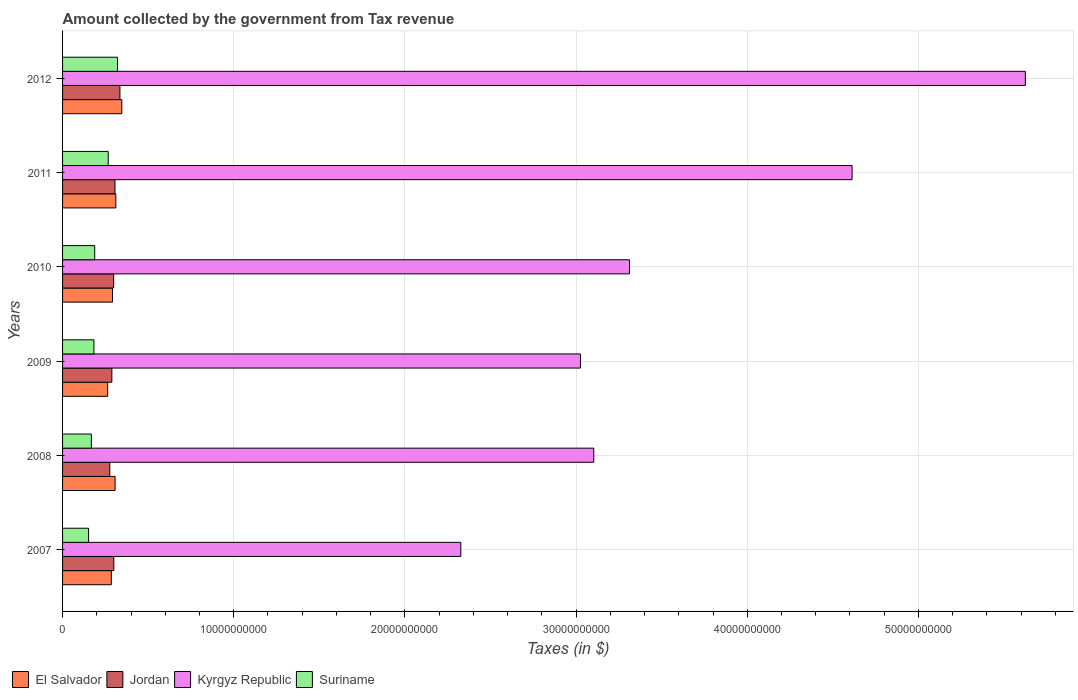Are the number of bars per tick equal to the number of legend labels?
Offer a very short reply. Yes. Are the number of bars on each tick of the Y-axis equal?
Your answer should be compact. Yes. What is the amount collected by the government from tax revenue in Suriname in 2008?
Offer a terse response. 1.68e+09. Across all years, what is the maximum amount collected by the government from tax revenue in Kyrgyz Republic?
Your answer should be compact. 5.62e+1. Across all years, what is the minimum amount collected by the government from tax revenue in El Salvador?
Your response must be concise. 2.64e+09. In which year was the amount collected by the government from tax revenue in El Salvador maximum?
Your response must be concise. 2012. What is the total amount collected by the government from tax revenue in Jordan in the graph?
Your answer should be very brief. 1.80e+1. What is the difference between the amount collected by the government from tax revenue in Jordan in 2008 and that in 2009?
Offer a terse response. -1.22e+08. What is the difference between the amount collected by the government from tax revenue in Suriname in 2008 and the amount collected by the government from tax revenue in El Salvador in 2012?
Give a very brief answer. -1.78e+09. What is the average amount collected by the government from tax revenue in Kyrgyz Republic per year?
Offer a terse response. 3.67e+1. In the year 2008, what is the difference between the amount collected by the government from tax revenue in Suriname and amount collected by the government from tax revenue in Kyrgyz Republic?
Offer a very short reply. -2.94e+1. What is the ratio of the amount collected by the government from tax revenue in Jordan in 2008 to that in 2011?
Ensure brevity in your answer.  0.9. Is the amount collected by the government from tax revenue in El Salvador in 2008 less than that in 2010?
Provide a succinct answer. No. Is the difference between the amount collected by the government from tax revenue in Suriname in 2011 and 2012 greater than the difference between the amount collected by the government from tax revenue in Kyrgyz Republic in 2011 and 2012?
Provide a short and direct response. Yes. What is the difference between the highest and the second highest amount collected by the government from tax revenue in Suriname?
Your response must be concise. 5.46e+08. What is the difference between the highest and the lowest amount collected by the government from tax revenue in Kyrgyz Republic?
Provide a short and direct response. 3.30e+1. Is the sum of the amount collected by the government from tax revenue in Jordan in 2008 and 2010 greater than the maximum amount collected by the government from tax revenue in Kyrgyz Republic across all years?
Keep it short and to the point. No. What does the 1st bar from the top in 2008 represents?
Keep it short and to the point. Suriname. What does the 2nd bar from the bottom in 2009 represents?
Your response must be concise. Jordan. Is it the case that in every year, the sum of the amount collected by the government from tax revenue in El Salvador and amount collected by the government from tax revenue in Kyrgyz Republic is greater than the amount collected by the government from tax revenue in Jordan?
Your response must be concise. Yes. Are all the bars in the graph horizontal?
Give a very brief answer. Yes. Does the graph contain any zero values?
Give a very brief answer. No. How many legend labels are there?
Give a very brief answer. 4. How are the legend labels stacked?
Keep it short and to the point. Horizontal. What is the title of the graph?
Make the answer very short. Amount collected by the government from Tax revenue. What is the label or title of the X-axis?
Your answer should be very brief. Taxes (in $). What is the Taxes (in $) of El Salvador in 2007?
Your response must be concise. 2.85e+09. What is the Taxes (in $) in Jordan in 2007?
Your answer should be very brief. 3.00e+09. What is the Taxes (in $) of Kyrgyz Republic in 2007?
Keep it short and to the point. 2.33e+1. What is the Taxes (in $) of Suriname in 2007?
Provide a succinct answer. 1.52e+09. What is the Taxes (in $) of El Salvador in 2008?
Offer a very short reply. 3.07e+09. What is the Taxes (in $) in Jordan in 2008?
Provide a short and direct response. 2.76e+09. What is the Taxes (in $) in Kyrgyz Republic in 2008?
Your response must be concise. 3.10e+1. What is the Taxes (in $) of Suriname in 2008?
Offer a terse response. 1.68e+09. What is the Taxes (in $) of El Salvador in 2009?
Ensure brevity in your answer.  2.64e+09. What is the Taxes (in $) in Jordan in 2009?
Your response must be concise. 2.88e+09. What is the Taxes (in $) in Kyrgyz Republic in 2009?
Offer a terse response. 3.03e+1. What is the Taxes (in $) of Suriname in 2009?
Offer a very short reply. 1.83e+09. What is the Taxes (in $) in El Salvador in 2010?
Keep it short and to the point. 2.92e+09. What is the Taxes (in $) of Jordan in 2010?
Your response must be concise. 2.99e+09. What is the Taxes (in $) in Kyrgyz Republic in 2010?
Provide a succinct answer. 3.31e+1. What is the Taxes (in $) in Suriname in 2010?
Your response must be concise. 1.88e+09. What is the Taxes (in $) of El Salvador in 2011?
Your response must be concise. 3.11e+09. What is the Taxes (in $) of Jordan in 2011?
Make the answer very short. 3.06e+09. What is the Taxes (in $) of Kyrgyz Republic in 2011?
Ensure brevity in your answer.  4.61e+1. What is the Taxes (in $) in Suriname in 2011?
Offer a terse response. 2.67e+09. What is the Taxes (in $) of El Salvador in 2012?
Your response must be concise. 3.46e+09. What is the Taxes (in $) in Jordan in 2012?
Ensure brevity in your answer.  3.35e+09. What is the Taxes (in $) in Kyrgyz Republic in 2012?
Give a very brief answer. 5.62e+1. What is the Taxes (in $) in Suriname in 2012?
Your answer should be very brief. 3.21e+09. Across all years, what is the maximum Taxes (in $) of El Salvador?
Provide a succinct answer. 3.46e+09. Across all years, what is the maximum Taxes (in $) of Jordan?
Keep it short and to the point. 3.35e+09. Across all years, what is the maximum Taxes (in $) in Kyrgyz Republic?
Your answer should be compact. 5.62e+1. Across all years, what is the maximum Taxes (in $) of Suriname?
Ensure brevity in your answer.  3.21e+09. Across all years, what is the minimum Taxes (in $) of El Salvador?
Provide a succinct answer. 2.64e+09. Across all years, what is the minimum Taxes (in $) in Jordan?
Ensure brevity in your answer.  2.76e+09. Across all years, what is the minimum Taxes (in $) of Kyrgyz Republic?
Ensure brevity in your answer.  2.33e+1. Across all years, what is the minimum Taxes (in $) in Suriname?
Offer a very short reply. 1.52e+09. What is the total Taxes (in $) of El Salvador in the graph?
Your answer should be compact. 1.80e+1. What is the total Taxes (in $) of Jordan in the graph?
Make the answer very short. 1.80e+1. What is the total Taxes (in $) in Kyrgyz Republic in the graph?
Give a very brief answer. 2.20e+11. What is the total Taxes (in $) in Suriname in the graph?
Keep it short and to the point. 1.28e+1. What is the difference between the Taxes (in $) in El Salvador in 2007 and that in 2008?
Offer a terse response. -2.20e+08. What is the difference between the Taxes (in $) of Jordan in 2007 and that in 2008?
Your answer should be very brief. 2.37e+08. What is the difference between the Taxes (in $) of Kyrgyz Republic in 2007 and that in 2008?
Offer a terse response. -7.77e+09. What is the difference between the Taxes (in $) of Suriname in 2007 and that in 2008?
Provide a succinct answer. -1.62e+08. What is the difference between the Taxes (in $) of El Salvador in 2007 and that in 2009?
Offer a very short reply. 2.12e+08. What is the difference between the Taxes (in $) of Jordan in 2007 and that in 2009?
Give a very brief answer. 1.15e+08. What is the difference between the Taxes (in $) of Kyrgyz Republic in 2007 and that in 2009?
Your answer should be very brief. -6.99e+09. What is the difference between the Taxes (in $) of Suriname in 2007 and that in 2009?
Give a very brief answer. -3.11e+08. What is the difference between the Taxes (in $) in El Salvador in 2007 and that in 2010?
Your answer should be very brief. -6.84e+07. What is the difference between the Taxes (in $) of Jordan in 2007 and that in 2010?
Provide a short and direct response. 9.30e+06. What is the difference between the Taxes (in $) of Kyrgyz Republic in 2007 and that in 2010?
Provide a succinct answer. -9.86e+09. What is the difference between the Taxes (in $) in Suriname in 2007 and that in 2010?
Ensure brevity in your answer.  -3.57e+08. What is the difference between the Taxes (in $) of El Salvador in 2007 and that in 2011?
Make the answer very short. -2.64e+08. What is the difference between the Taxes (in $) of Jordan in 2007 and that in 2011?
Provide a succinct answer. -6.70e+07. What is the difference between the Taxes (in $) of Kyrgyz Republic in 2007 and that in 2011?
Give a very brief answer. -2.29e+1. What is the difference between the Taxes (in $) of Suriname in 2007 and that in 2011?
Your answer should be compact. -1.15e+09. What is the difference between the Taxes (in $) in El Salvador in 2007 and that in 2012?
Provide a short and direct response. -6.12e+08. What is the difference between the Taxes (in $) of Jordan in 2007 and that in 2012?
Your answer should be compact. -3.56e+08. What is the difference between the Taxes (in $) of Kyrgyz Republic in 2007 and that in 2012?
Your answer should be very brief. -3.30e+1. What is the difference between the Taxes (in $) in Suriname in 2007 and that in 2012?
Provide a short and direct response. -1.69e+09. What is the difference between the Taxes (in $) of El Salvador in 2008 and that in 2009?
Your answer should be compact. 4.32e+08. What is the difference between the Taxes (in $) in Jordan in 2008 and that in 2009?
Keep it short and to the point. -1.22e+08. What is the difference between the Taxes (in $) in Kyrgyz Republic in 2008 and that in 2009?
Your response must be concise. 7.79e+08. What is the difference between the Taxes (in $) in Suriname in 2008 and that in 2009?
Offer a terse response. -1.49e+08. What is the difference between the Taxes (in $) in El Salvador in 2008 and that in 2010?
Make the answer very short. 1.52e+08. What is the difference between the Taxes (in $) in Jordan in 2008 and that in 2010?
Your response must be concise. -2.28e+08. What is the difference between the Taxes (in $) in Kyrgyz Republic in 2008 and that in 2010?
Your answer should be compact. -2.09e+09. What is the difference between the Taxes (in $) of Suriname in 2008 and that in 2010?
Your answer should be compact. -1.95e+08. What is the difference between the Taxes (in $) in El Salvador in 2008 and that in 2011?
Provide a short and direct response. -4.38e+07. What is the difference between the Taxes (in $) of Jordan in 2008 and that in 2011?
Your response must be concise. -3.04e+08. What is the difference between the Taxes (in $) in Kyrgyz Republic in 2008 and that in 2011?
Make the answer very short. -1.51e+1. What is the difference between the Taxes (in $) in Suriname in 2008 and that in 2011?
Provide a succinct answer. -9.84e+08. What is the difference between the Taxes (in $) in El Salvador in 2008 and that in 2012?
Provide a succinct answer. -3.92e+08. What is the difference between the Taxes (in $) in Jordan in 2008 and that in 2012?
Offer a terse response. -5.93e+08. What is the difference between the Taxes (in $) in Kyrgyz Republic in 2008 and that in 2012?
Keep it short and to the point. -2.52e+1. What is the difference between the Taxes (in $) in Suriname in 2008 and that in 2012?
Give a very brief answer. -1.53e+09. What is the difference between the Taxes (in $) in El Salvador in 2009 and that in 2010?
Make the answer very short. -2.81e+08. What is the difference between the Taxes (in $) of Jordan in 2009 and that in 2010?
Your answer should be very brief. -1.06e+08. What is the difference between the Taxes (in $) of Kyrgyz Republic in 2009 and that in 2010?
Provide a short and direct response. -2.87e+09. What is the difference between the Taxes (in $) of Suriname in 2009 and that in 2010?
Your answer should be compact. -4.60e+07. What is the difference between the Taxes (in $) in El Salvador in 2009 and that in 2011?
Give a very brief answer. -4.76e+08. What is the difference between the Taxes (in $) in Jordan in 2009 and that in 2011?
Offer a very short reply. -1.82e+08. What is the difference between the Taxes (in $) in Kyrgyz Republic in 2009 and that in 2011?
Make the answer very short. -1.59e+1. What is the difference between the Taxes (in $) in Suriname in 2009 and that in 2011?
Keep it short and to the point. -8.35e+08. What is the difference between the Taxes (in $) of El Salvador in 2009 and that in 2012?
Your answer should be compact. -8.25e+08. What is the difference between the Taxes (in $) in Jordan in 2009 and that in 2012?
Offer a very short reply. -4.72e+08. What is the difference between the Taxes (in $) of Kyrgyz Republic in 2009 and that in 2012?
Keep it short and to the point. -2.60e+1. What is the difference between the Taxes (in $) of Suriname in 2009 and that in 2012?
Offer a very short reply. -1.38e+09. What is the difference between the Taxes (in $) of El Salvador in 2010 and that in 2011?
Make the answer very short. -1.95e+08. What is the difference between the Taxes (in $) in Jordan in 2010 and that in 2011?
Provide a short and direct response. -7.63e+07. What is the difference between the Taxes (in $) of Kyrgyz Republic in 2010 and that in 2011?
Offer a terse response. -1.30e+1. What is the difference between the Taxes (in $) in Suriname in 2010 and that in 2011?
Offer a terse response. -7.89e+08. What is the difference between the Taxes (in $) of El Salvador in 2010 and that in 2012?
Give a very brief answer. -5.44e+08. What is the difference between the Taxes (in $) in Jordan in 2010 and that in 2012?
Offer a very short reply. -3.66e+08. What is the difference between the Taxes (in $) of Kyrgyz Republic in 2010 and that in 2012?
Offer a very short reply. -2.31e+1. What is the difference between the Taxes (in $) of Suriname in 2010 and that in 2012?
Your answer should be very brief. -1.33e+09. What is the difference between the Taxes (in $) in El Salvador in 2011 and that in 2012?
Offer a very short reply. -3.48e+08. What is the difference between the Taxes (in $) in Jordan in 2011 and that in 2012?
Make the answer very short. -2.89e+08. What is the difference between the Taxes (in $) of Kyrgyz Republic in 2011 and that in 2012?
Provide a short and direct response. -1.01e+1. What is the difference between the Taxes (in $) in Suriname in 2011 and that in 2012?
Provide a succinct answer. -5.46e+08. What is the difference between the Taxes (in $) of El Salvador in 2007 and the Taxes (in $) of Jordan in 2008?
Ensure brevity in your answer.  9.05e+07. What is the difference between the Taxes (in $) in El Salvador in 2007 and the Taxes (in $) in Kyrgyz Republic in 2008?
Make the answer very short. -2.82e+1. What is the difference between the Taxes (in $) in El Salvador in 2007 and the Taxes (in $) in Suriname in 2008?
Offer a very short reply. 1.17e+09. What is the difference between the Taxes (in $) in Jordan in 2007 and the Taxes (in $) in Kyrgyz Republic in 2008?
Provide a short and direct response. -2.80e+1. What is the difference between the Taxes (in $) of Jordan in 2007 and the Taxes (in $) of Suriname in 2008?
Make the answer very short. 1.31e+09. What is the difference between the Taxes (in $) of Kyrgyz Republic in 2007 and the Taxes (in $) of Suriname in 2008?
Provide a short and direct response. 2.16e+1. What is the difference between the Taxes (in $) in El Salvador in 2007 and the Taxes (in $) in Jordan in 2009?
Ensure brevity in your answer.  -3.13e+07. What is the difference between the Taxes (in $) in El Salvador in 2007 and the Taxes (in $) in Kyrgyz Republic in 2009?
Your response must be concise. -2.74e+1. What is the difference between the Taxes (in $) in El Salvador in 2007 and the Taxes (in $) in Suriname in 2009?
Ensure brevity in your answer.  1.02e+09. What is the difference between the Taxes (in $) of Jordan in 2007 and the Taxes (in $) of Kyrgyz Republic in 2009?
Ensure brevity in your answer.  -2.73e+1. What is the difference between the Taxes (in $) of Jordan in 2007 and the Taxes (in $) of Suriname in 2009?
Ensure brevity in your answer.  1.16e+09. What is the difference between the Taxes (in $) of Kyrgyz Republic in 2007 and the Taxes (in $) of Suriname in 2009?
Offer a very short reply. 2.14e+1. What is the difference between the Taxes (in $) in El Salvador in 2007 and the Taxes (in $) in Jordan in 2010?
Give a very brief answer. -1.37e+08. What is the difference between the Taxes (in $) in El Salvador in 2007 and the Taxes (in $) in Kyrgyz Republic in 2010?
Offer a terse response. -3.03e+1. What is the difference between the Taxes (in $) in El Salvador in 2007 and the Taxes (in $) in Suriname in 2010?
Offer a very short reply. 9.71e+08. What is the difference between the Taxes (in $) in Jordan in 2007 and the Taxes (in $) in Kyrgyz Republic in 2010?
Keep it short and to the point. -3.01e+1. What is the difference between the Taxes (in $) in Jordan in 2007 and the Taxes (in $) in Suriname in 2010?
Make the answer very short. 1.12e+09. What is the difference between the Taxes (in $) in Kyrgyz Republic in 2007 and the Taxes (in $) in Suriname in 2010?
Your answer should be compact. 2.14e+1. What is the difference between the Taxes (in $) in El Salvador in 2007 and the Taxes (in $) in Jordan in 2011?
Make the answer very short. -2.14e+08. What is the difference between the Taxes (in $) in El Salvador in 2007 and the Taxes (in $) in Kyrgyz Republic in 2011?
Provide a short and direct response. -4.33e+1. What is the difference between the Taxes (in $) in El Salvador in 2007 and the Taxes (in $) in Suriname in 2011?
Offer a terse response. 1.82e+08. What is the difference between the Taxes (in $) in Jordan in 2007 and the Taxes (in $) in Kyrgyz Republic in 2011?
Provide a short and direct response. -4.31e+1. What is the difference between the Taxes (in $) in Jordan in 2007 and the Taxes (in $) in Suriname in 2011?
Give a very brief answer. 3.29e+08. What is the difference between the Taxes (in $) of Kyrgyz Republic in 2007 and the Taxes (in $) of Suriname in 2011?
Give a very brief answer. 2.06e+1. What is the difference between the Taxes (in $) in El Salvador in 2007 and the Taxes (in $) in Jordan in 2012?
Provide a short and direct response. -5.03e+08. What is the difference between the Taxes (in $) in El Salvador in 2007 and the Taxes (in $) in Kyrgyz Republic in 2012?
Your answer should be very brief. -5.34e+1. What is the difference between the Taxes (in $) in El Salvador in 2007 and the Taxes (in $) in Suriname in 2012?
Provide a succinct answer. -3.64e+08. What is the difference between the Taxes (in $) of Jordan in 2007 and the Taxes (in $) of Kyrgyz Republic in 2012?
Provide a short and direct response. -5.33e+1. What is the difference between the Taxes (in $) in Jordan in 2007 and the Taxes (in $) in Suriname in 2012?
Keep it short and to the point. -2.17e+08. What is the difference between the Taxes (in $) of Kyrgyz Republic in 2007 and the Taxes (in $) of Suriname in 2012?
Offer a very short reply. 2.01e+1. What is the difference between the Taxes (in $) of El Salvador in 2008 and the Taxes (in $) of Jordan in 2009?
Provide a succinct answer. 1.89e+08. What is the difference between the Taxes (in $) in El Salvador in 2008 and the Taxes (in $) in Kyrgyz Republic in 2009?
Ensure brevity in your answer.  -2.72e+1. What is the difference between the Taxes (in $) in El Salvador in 2008 and the Taxes (in $) in Suriname in 2009?
Give a very brief answer. 1.24e+09. What is the difference between the Taxes (in $) of Jordan in 2008 and the Taxes (in $) of Kyrgyz Republic in 2009?
Provide a succinct answer. -2.75e+1. What is the difference between the Taxes (in $) of Jordan in 2008 and the Taxes (in $) of Suriname in 2009?
Provide a succinct answer. 9.26e+08. What is the difference between the Taxes (in $) in Kyrgyz Republic in 2008 and the Taxes (in $) in Suriname in 2009?
Provide a succinct answer. 2.92e+1. What is the difference between the Taxes (in $) of El Salvador in 2008 and the Taxes (in $) of Jordan in 2010?
Ensure brevity in your answer.  8.27e+07. What is the difference between the Taxes (in $) in El Salvador in 2008 and the Taxes (in $) in Kyrgyz Republic in 2010?
Your response must be concise. -3.01e+1. What is the difference between the Taxes (in $) of El Salvador in 2008 and the Taxes (in $) of Suriname in 2010?
Provide a succinct answer. 1.19e+09. What is the difference between the Taxes (in $) of Jordan in 2008 and the Taxes (in $) of Kyrgyz Republic in 2010?
Provide a short and direct response. -3.04e+1. What is the difference between the Taxes (in $) in Jordan in 2008 and the Taxes (in $) in Suriname in 2010?
Give a very brief answer. 8.80e+08. What is the difference between the Taxes (in $) of Kyrgyz Republic in 2008 and the Taxes (in $) of Suriname in 2010?
Your response must be concise. 2.92e+1. What is the difference between the Taxes (in $) in El Salvador in 2008 and the Taxes (in $) in Jordan in 2011?
Provide a succinct answer. 6.40e+06. What is the difference between the Taxes (in $) of El Salvador in 2008 and the Taxes (in $) of Kyrgyz Republic in 2011?
Your response must be concise. -4.31e+1. What is the difference between the Taxes (in $) of El Salvador in 2008 and the Taxes (in $) of Suriname in 2011?
Offer a very short reply. 4.02e+08. What is the difference between the Taxes (in $) in Jordan in 2008 and the Taxes (in $) in Kyrgyz Republic in 2011?
Provide a succinct answer. -4.34e+1. What is the difference between the Taxes (in $) of Jordan in 2008 and the Taxes (in $) of Suriname in 2011?
Your response must be concise. 9.14e+07. What is the difference between the Taxes (in $) of Kyrgyz Republic in 2008 and the Taxes (in $) of Suriname in 2011?
Provide a succinct answer. 2.84e+1. What is the difference between the Taxes (in $) of El Salvador in 2008 and the Taxes (in $) of Jordan in 2012?
Provide a short and direct response. -2.83e+08. What is the difference between the Taxes (in $) of El Salvador in 2008 and the Taxes (in $) of Kyrgyz Republic in 2012?
Give a very brief answer. -5.32e+1. What is the difference between the Taxes (in $) of El Salvador in 2008 and the Taxes (in $) of Suriname in 2012?
Keep it short and to the point. -1.44e+08. What is the difference between the Taxes (in $) of Jordan in 2008 and the Taxes (in $) of Kyrgyz Republic in 2012?
Ensure brevity in your answer.  -5.35e+1. What is the difference between the Taxes (in $) of Jordan in 2008 and the Taxes (in $) of Suriname in 2012?
Your answer should be very brief. -4.54e+08. What is the difference between the Taxes (in $) in Kyrgyz Republic in 2008 and the Taxes (in $) in Suriname in 2012?
Give a very brief answer. 2.78e+1. What is the difference between the Taxes (in $) in El Salvador in 2009 and the Taxes (in $) in Jordan in 2010?
Make the answer very short. -3.50e+08. What is the difference between the Taxes (in $) in El Salvador in 2009 and the Taxes (in $) in Kyrgyz Republic in 2010?
Offer a terse response. -3.05e+1. What is the difference between the Taxes (in $) of El Salvador in 2009 and the Taxes (in $) of Suriname in 2010?
Provide a succinct answer. 7.58e+08. What is the difference between the Taxes (in $) in Jordan in 2009 and the Taxes (in $) in Kyrgyz Republic in 2010?
Give a very brief answer. -3.02e+1. What is the difference between the Taxes (in $) in Jordan in 2009 and the Taxes (in $) in Suriname in 2010?
Ensure brevity in your answer.  1.00e+09. What is the difference between the Taxes (in $) in Kyrgyz Republic in 2009 and the Taxes (in $) in Suriname in 2010?
Ensure brevity in your answer.  2.84e+1. What is the difference between the Taxes (in $) of El Salvador in 2009 and the Taxes (in $) of Jordan in 2011?
Keep it short and to the point. -4.26e+08. What is the difference between the Taxes (in $) of El Salvador in 2009 and the Taxes (in $) of Kyrgyz Republic in 2011?
Offer a terse response. -4.35e+1. What is the difference between the Taxes (in $) in El Salvador in 2009 and the Taxes (in $) in Suriname in 2011?
Provide a short and direct response. -3.05e+07. What is the difference between the Taxes (in $) in Jordan in 2009 and the Taxes (in $) in Kyrgyz Republic in 2011?
Your answer should be compact. -4.32e+1. What is the difference between the Taxes (in $) in Jordan in 2009 and the Taxes (in $) in Suriname in 2011?
Your answer should be compact. 2.13e+08. What is the difference between the Taxes (in $) of Kyrgyz Republic in 2009 and the Taxes (in $) of Suriname in 2011?
Keep it short and to the point. 2.76e+1. What is the difference between the Taxes (in $) of El Salvador in 2009 and the Taxes (in $) of Jordan in 2012?
Keep it short and to the point. -7.15e+08. What is the difference between the Taxes (in $) of El Salvador in 2009 and the Taxes (in $) of Kyrgyz Republic in 2012?
Your answer should be compact. -5.36e+1. What is the difference between the Taxes (in $) in El Salvador in 2009 and the Taxes (in $) in Suriname in 2012?
Make the answer very short. -5.76e+08. What is the difference between the Taxes (in $) of Jordan in 2009 and the Taxes (in $) of Kyrgyz Republic in 2012?
Provide a short and direct response. -5.34e+1. What is the difference between the Taxes (in $) of Jordan in 2009 and the Taxes (in $) of Suriname in 2012?
Offer a terse response. -3.33e+08. What is the difference between the Taxes (in $) in Kyrgyz Republic in 2009 and the Taxes (in $) in Suriname in 2012?
Ensure brevity in your answer.  2.70e+1. What is the difference between the Taxes (in $) in El Salvador in 2010 and the Taxes (in $) in Jordan in 2011?
Your response must be concise. -1.45e+08. What is the difference between the Taxes (in $) of El Salvador in 2010 and the Taxes (in $) of Kyrgyz Republic in 2011?
Provide a short and direct response. -4.32e+1. What is the difference between the Taxes (in $) in El Salvador in 2010 and the Taxes (in $) in Suriname in 2011?
Your response must be concise. 2.50e+08. What is the difference between the Taxes (in $) of Jordan in 2010 and the Taxes (in $) of Kyrgyz Republic in 2011?
Your answer should be compact. -4.31e+1. What is the difference between the Taxes (in $) of Jordan in 2010 and the Taxes (in $) of Suriname in 2011?
Provide a short and direct response. 3.19e+08. What is the difference between the Taxes (in $) of Kyrgyz Republic in 2010 and the Taxes (in $) of Suriname in 2011?
Your answer should be compact. 3.05e+1. What is the difference between the Taxes (in $) in El Salvador in 2010 and the Taxes (in $) in Jordan in 2012?
Keep it short and to the point. -4.34e+08. What is the difference between the Taxes (in $) of El Salvador in 2010 and the Taxes (in $) of Kyrgyz Republic in 2012?
Offer a very short reply. -5.33e+1. What is the difference between the Taxes (in $) in El Salvador in 2010 and the Taxes (in $) in Suriname in 2012?
Ensure brevity in your answer.  -2.95e+08. What is the difference between the Taxes (in $) in Jordan in 2010 and the Taxes (in $) in Kyrgyz Republic in 2012?
Provide a succinct answer. -5.33e+1. What is the difference between the Taxes (in $) in Jordan in 2010 and the Taxes (in $) in Suriname in 2012?
Your answer should be compact. -2.27e+08. What is the difference between the Taxes (in $) in Kyrgyz Republic in 2010 and the Taxes (in $) in Suriname in 2012?
Provide a succinct answer. 2.99e+1. What is the difference between the Taxes (in $) of El Salvador in 2011 and the Taxes (in $) of Jordan in 2012?
Your response must be concise. -2.39e+08. What is the difference between the Taxes (in $) in El Salvador in 2011 and the Taxes (in $) in Kyrgyz Republic in 2012?
Give a very brief answer. -5.31e+1. What is the difference between the Taxes (in $) of El Salvador in 2011 and the Taxes (in $) of Suriname in 2012?
Offer a terse response. -1.00e+08. What is the difference between the Taxes (in $) of Jordan in 2011 and the Taxes (in $) of Kyrgyz Republic in 2012?
Your answer should be compact. -5.32e+1. What is the difference between the Taxes (in $) of Jordan in 2011 and the Taxes (in $) of Suriname in 2012?
Give a very brief answer. -1.50e+08. What is the difference between the Taxes (in $) of Kyrgyz Republic in 2011 and the Taxes (in $) of Suriname in 2012?
Ensure brevity in your answer.  4.29e+1. What is the average Taxes (in $) in El Salvador per year?
Provide a succinct answer. 3.01e+09. What is the average Taxes (in $) in Jordan per year?
Ensure brevity in your answer.  3.01e+09. What is the average Taxes (in $) in Kyrgyz Republic per year?
Ensure brevity in your answer.  3.67e+1. What is the average Taxes (in $) in Suriname per year?
Provide a short and direct response. 2.13e+09. In the year 2007, what is the difference between the Taxes (in $) in El Salvador and Taxes (in $) in Jordan?
Your answer should be compact. -1.47e+08. In the year 2007, what is the difference between the Taxes (in $) in El Salvador and Taxes (in $) in Kyrgyz Republic?
Provide a short and direct response. -2.04e+1. In the year 2007, what is the difference between the Taxes (in $) in El Salvador and Taxes (in $) in Suriname?
Make the answer very short. 1.33e+09. In the year 2007, what is the difference between the Taxes (in $) in Jordan and Taxes (in $) in Kyrgyz Republic?
Offer a terse response. -2.03e+1. In the year 2007, what is the difference between the Taxes (in $) in Jordan and Taxes (in $) in Suriname?
Give a very brief answer. 1.47e+09. In the year 2007, what is the difference between the Taxes (in $) in Kyrgyz Republic and Taxes (in $) in Suriname?
Offer a terse response. 2.17e+1. In the year 2008, what is the difference between the Taxes (in $) of El Salvador and Taxes (in $) of Jordan?
Offer a terse response. 3.10e+08. In the year 2008, what is the difference between the Taxes (in $) in El Salvador and Taxes (in $) in Kyrgyz Republic?
Provide a succinct answer. -2.80e+1. In the year 2008, what is the difference between the Taxes (in $) of El Salvador and Taxes (in $) of Suriname?
Provide a succinct answer. 1.39e+09. In the year 2008, what is the difference between the Taxes (in $) in Jordan and Taxes (in $) in Kyrgyz Republic?
Provide a short and direct response. -2.83e+1. In the year 2008, what is the difference between the Taxes (in $) of Jordan and Taxes (in $) of Suriname?
Offer a terse response. 1.08e+09. In the year 2008, what is the difference between the Taxes (in $) in Kyrgyz Republic and Taxes (in $) in Suriname?
Your response must be concise. 2.94e+1. In the year 2009, what is the difference between the Taxes (in $) in El Salvador and Taxes (in $) in Jordan?
Your answer should be compact. -2.44e+08. In the year 2009, what is the difference between the Taxes (in $) in El Salvador and Taxes (in $) in Kyrgyz Republic?
Give a very brief answer. -2.76e+1. In the year 2009, what is the difference between the Taxes (in $) in El Salvador and Taxes (in $) in Suriname?
Provide a succinct answer. 8.04e+08. In the year 2009, what is the difference between the Taxes (in $) in Jordan and Taxes (in $) in Kyrgyz Republic?
Provide a short and direct response. -2.74e+1. In the year 2009, what is the difference between the Taxes (in $) in Jordan and Taxes (in $) in Suriname?
Offer a very short reply. 1.05e+09. In the year 2009, what is the difference between the Taxes (in $) of Kyrgyz Republic and Taxes (in $) of Suriname?
Provide a short and direct response. 2.84e+1. In the year 2010, what is the difference between the Taxes (in $) of El Salvador and Taxes (in $) of Jordan?
Ensure brevity in your answer.  -6.89e+07. In the year 2010, what is the difference between the Taxes (in $) in El Salvador and Taxes (in $) in Kyrgyz Republic?
Provide a succinct answer. -3.02e+1. In the year 2010, what is the difference between the Taxes (in $) in El Salvador and Taxes (in $) in Suriname?
Offer a terse response. 1.04e+09. In the year 2010, what is the difference between the Taxes (in $) of Jordan and Taxes (in $) of Kyrgyz Republic?
Your response must be concise. -3.01e+1. In the year 2010, what is the difference between the Taxes (in $) of Jordan and Taxes (in $) of Suriname?
Ensure brevity in your answer.  1.11e+09. In the year 2010, what is the difference between the Taxes (in $) of Kyrgyz Republic and Taxes (in $) of Suriname?
Provide a short and direct response. 3.12e+1. In the year 2011, what is the difference between the Taxes (in $) in El Salvador and Taxes (in $) in Jordan?
Your response must be concise. 5.02e+07. In the year 2011, what is the difference between the Taxes (in $) in El Salvador and Taxes (in $) in Kyrgyz Republic?
Your answer should be compact. -4.30e+1. In the year 2011, what is the difference between the Taxes (in $) in El Salvador and Taxes (in $) in Suriname?
Give a very brief answer. 4.46e+08. In the year 2011, what is the difference between the Taxes (in $) in Jordan and Taxes (in $) in Kyrgyz Republic?
Give a very brief answer. -4.31e+1. In the year 2011, what is the difference between the Taxes (in $) in Jordan and Taxes (in $) in Suriname?
Keep it short and to the point. 3.96e+08. In the year 2011, what is the difference between the Taxes (in $) in Kyrgyz Republic and Taxes (in $) in Suriname?
Provide a succinct answer. 4.35e+1. In the year 2012, what is the difference between the Taxes (in $) in El Salvador and Taxes (in $) in Jordan?
Give a very brief answer. 1.09e+08. In the year 2012, what is the difference between the Taxes (in $) in El Salvador and Taxes (in $) in Kyrgyz Republic?
Your answer should be compact. -5.28e+1. In the year 2012, what is the difference between the Taxes (in $) in El Salvador and Taxes (in $) in Suriname?
Keep it short and to the point. 2.48e+08. In the year 2012, what is the difference between the Taxes (in $) of Jordan and Taxes (in $) of Kyrgyz Republic?
Provide a succinct answer. -5.29e+1. In the year 2012, what is the difference between the Taxes (in $) of Jordan and Taxes (in $) of Suriname?
Your answer should be compact. 1.39e+08. In the year 2012, what is the difference between the Taxes (in $) in Kyrgyz Republic and Taxes (in $) in Suriname?
Make the answer very short. 5.30e+1. What is the ratio of the Taxes (in $) of El Salvador in 2007 to that in 2008?
Keep it short and to the point. 0.93. What is the ratio of the Taxes (in $) in Jordan in 2007 to that in 2008?
Offer a very short reply. 1.09. What is the ratio of the Taxes (in $) of Kyrgyz Republic in 2007 to that in 2008?
Offer a very short reply. 0.75. What is the ratio of the Taxes (in $) in Suriname in 2007 to that in 2008?
Keep it short and to the point. 0.9. What is the ratio of the Taxes (in $) of El Salvador in 2007 to that in 2009?
Your answer should be compact. 1.08. What is the ratio of the Taxes (in $) in Jordan in 2007 to that in 2009?
Make the answer very short. 1.04. What is the ratio of the Taxes (in $) in Kyrgyz Republic in 2007 to that in 2009?
Provide a succinct answer. 0.77. What is the ratio of the Taxes (in $) in Suriname in 2007 to that in 2009?
Ensure brevity in your answer.  0.83. What is the ratio of the Taxes (in $) in El Salvador in 2007 to that in 2010?
Offer a very short reply. 0.98. What is the ratio of the Taxes (in $) in Jordan in 2007 to that in 2010?
Your answer should be compact. 1. What is the ratio of the Taxes (in $) of Kyrgyz Republic in 2007 to that in 2010?
Your answer should be compact. 0.7. What is the ratio of the Taxes (in $) in Suriname in 2007 to that in 2010?
Give a very brief answer. 0.81. What is the ratio of the Taxes (in $) of El Salvador in 2007 to that in 2011?
Your answer should be compact. 0.92. What is the ratio of the Taxes (in $) of Jordan in 2007 to that in 2011?
Your response must be concise. 0.98. What is the ratio of the Taxes (in $) in Kyrgyz Republic in 2007 to that in 2011?
Ensure brevity in your answer.  0.5. What is the ratio of the Taxes (in $) of Suriname in 2007 to that in 2011?
Make the answer very short. 0.57. What is the ratio of the Taxes (in $) in El Salvador in 2007 to that in 2012?
Your answer should be very brief. 0.82. What is the ratio of the Taxes (in $) of Jordan in 2007 to that in 2012?
Offer a very short reply. 0.89. What is the ratio of the Taxes (in $) in Kyrgyz Republic in 2007 to that in 2012?
Make the answer very short. 0.41. What is the ratio of the Taxes (in $) in Suriname in 2007 to that in 2012?
Give a very brief answer. 0.47. What is the ratio of the Taxes (in $) in El Salvador in 2008 to that in 2009?
Provide a short and direct response. 1.16. What is the ratio of the Taxes (in $) in Jordan in 2008 to that in 2009?
Your answer should be compact. 0.96. What is the ratio of the Taxes (in $) in Kyrgyz Republic in 2008 to that in 2009?
Provide a succinct answer. 1.03. What is the ratio of the Taxes (in $) in Suriname in 2008 to that in 2009?
Make the answer very short. 0.92. What is the ratio of the Taxes (in $) in El Salvador in 2008 to that in 2010?
Give a very brief answer. 1.05. What is the ratio of the Taxes (in $) of Jordan in 2008 to that in 2010?
Give a very brief answer. 0.92. What is the ratio of the Taxes (in $) in Kyrgyz Republic in 2008 to that in 2010?
Make the answer very short. 0.94. What is the ratio of the Taxes (in $) in Suriname in 2008 to that in 2010?
Offer a terse response. 0.9. What is the ratio of the Taxes (in $) of El Salvador in 2008 to that in 2011?
Offer a terse response. 0.99. What is the ratio of the Taxes (in $) in Jordan in 2008 to that in 2011?
Keep it short and to the point. 0.9. What is the ratio of the Taxes (in $) of Kyrgyz Republic in 2008 to that in 2011?
Give a very brief answer. 0.67. What is the ratio of the Taxes (in $) of Suriname in 2008 to that in 2011?
Make the answer very short. 0.63. What is the ratio of the Taxes (in $) in El Salvador in 2008 to that in 2012?
Offer a very short reply. 0.89. What is the ratio of the Taxes (in $) in Jordan in 2008 to that in 2012?
Give a very brief answer. 0.82. What is the ratio of the Taxes (in $) of Kyrgyz Republic in 2008 to that in 2012?
Provide a short and direct response. 0.55. What is the ratio of the Taxes (in $) of Suriname in 2008 to that in 2012?
Make the answer very short. 0.52. What is the ratio of the Taxes (in $) in El Salvador in 2009 to that in 2010?
Your answer should be compact. 0.9. What is the ratio of the Taxes (in $) in Jordan in 2009 to that in 2010?
Keep it short and to the point. 0.96. What is the ratio of the Taxes (in $) in Kyrgyz Republic in 2009 to that in 2010?
Your answer should be compact. 0.91. What is the ratio of the Taxes (in $) in Suriname in 2009 to that in 2010?
Your answer should be compact. 0.98. What is the ratio of the Taxes (in $) in El Salvador in 2009 to that in 2011?
Give a very brief answer. 0.85. What is the ratio of the Taxes (in $) of Jordan in 2009 to that in 2011?
Offer a terse response. 0.94. What is the ratio of the Taxes (in $) of Kyrgyz Republic in 2009 to that in 2011?
Make the answer very short. 0.66. What is the ratio of the Taxes (in $) in Suriname in 2009 to that in 2011?
Your answer should be compact. 0.69. What is the ratio of the Taxes (in $) in El Salvador in 2009 to that in 2012?
Provide a succinct answer. 0.76. What is the ratio of the Taxes (in $) of Jordan in 2009 to that in 2012?
Provide a succinct answer. 0.86. What is the ratio of the Taxes (in $) in Kyrgyz Republic in 2009 to that in 2012?
Your answer should be compact. 0.54. What is the ratio of the Taxes (in $) of Suriname in 2009 to that in 2012?
Give a very brief answer. 0.57. What is the ratio of the Taxes (in $) of El Salvador in 2010 to that in 2011?
Provide a short and direct response. 0.94. What is the ratio of the Taxes (in $) in Jordan in 2010 to that in 2011?
Make the answer very short. 0.98. What is the ratio of the Taxes (in $) in Kyrgyz Republic in 2010 to that in 2011?
Make the answer very short. 0.72. What is the ratio of the Taxes (in $) of Suriname in 2010 to that in 2011?
Your answer should be very brief. 0.7. What is the ratio of the Taxes (in $) of El Salvador in 2010 to that in 2012?
Offer a terse response. 0.84. What is the ratio of the Taxes (in $) of Jordan in 2010 to that in 2012?
Offer a very short reply. 0.89. What is the ratio of the Taxes (in $) in Kyrgyz Republic in 2010 to that in 2012?
Ensure brevity in your answer.  0.59. What is the ratio of the Taxes (in $) in Suriname in 2010 to that in 2012?
Your answer should be very brief. 0.58. What is the ratio of the Taxes (in $) in El Salvador in 2011 to that in 2012?
Keep it short and to the point. 0.9. What is the ratio of the Taxes (in $) of Jordan in 2011 to that in 2012?
Keep it short and to the point. 0.91. What is the ratio of the Taxes (in $) in Kyrgyz Republic in 2011 to that in 2012?
Your response must be concise. 0.82. What is the ratio of the Taxes (in $) of Suriname in 2011 to that in 2012?
Keep it short and to the point. 0.83. What is the difference between the highest and the second highest Taxes (in $) of El Salvador?
Your answer should be compact. 3.48e+08. What is the difference between the highest and the second highest Taxes (in $) of Jordan?
Your answer should be compact. 2.89e+08. What is the difference between the highest and the second highest Taxes (in $) in Kyrgyz Republic?
Keep it short and to the point. 1.01e+1. What is the difference between the highest and the second highest Taxes (in $) of Suriname?
Provide a succinct answer. 5.46e+08. What is the difference between the highest and the lowest Taxes (in $) of El Salvador?
Keep it short and to the point. 8.25e+08. What is the difference between the highest and the lowest Taxes (in $) of Jordan?
Ensure brevity in your answer.  5.93e+08. What is the difference between the highest and the lowest Taxes (in $) in Kyrgyz Republic?
Your answer should be very brief. 3.30e+1. What is the difference between the highest and the lowest Taxes (in $) in Suriname?
Offer a very short reply. 1.69e+09. 